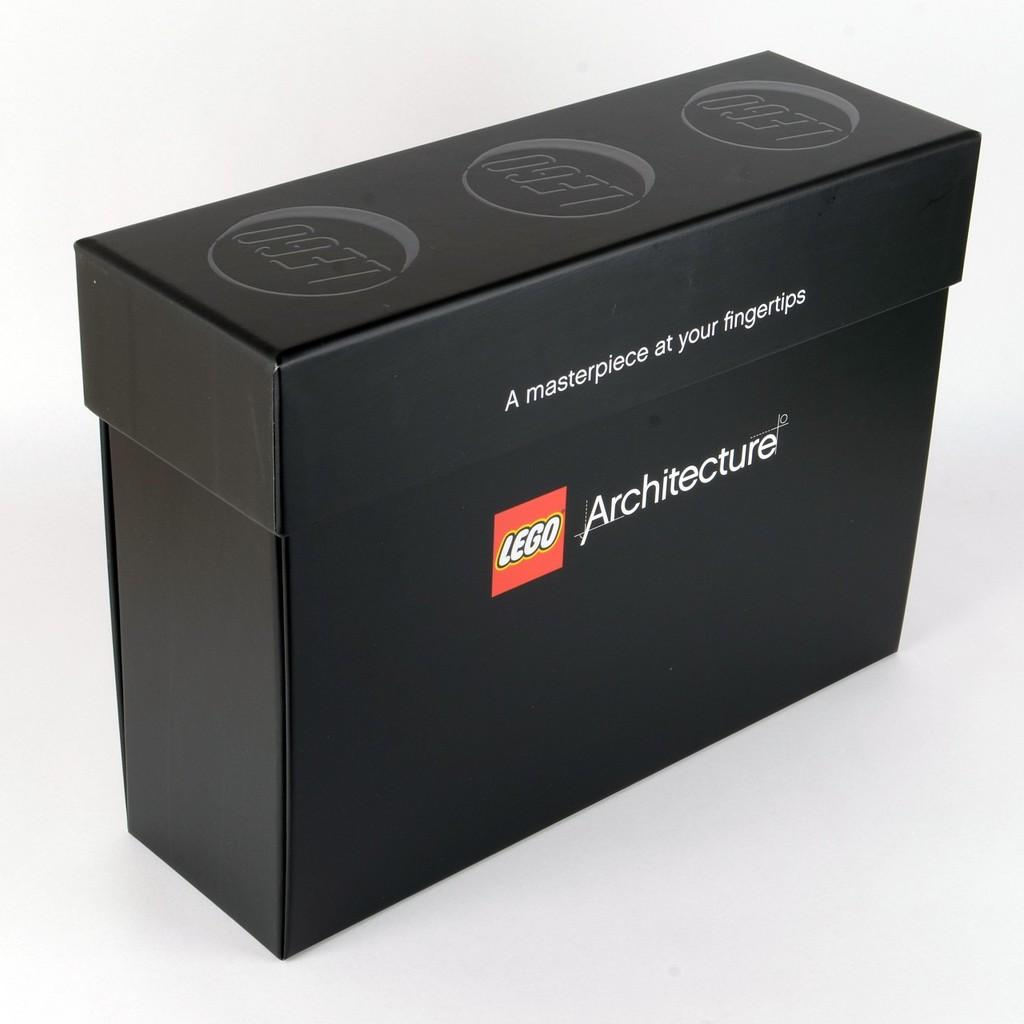<image>
Write a terse but informative summary of the picture. A black lego box with A masterpiece at your fingertips on the side. 